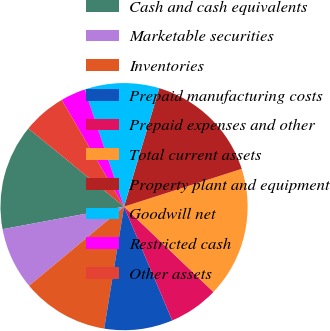Convert chart. <chart><loc_0><loc_0><loc_500><loc_500><pie_chart><fcel>Cash and cash equivalents<fcel>Marketable securities<fcel>Inventories<fcel>Prepaid manufacturing costs<fcel>Prepaid expenses and other<fcel>Total current assets<fcel>Property plant and equipment<fcel>Goodwill net<fcel>Restricted cash<fcel>Other assets<nl><fcel>13.82%<fcel>8.13%<fcel>11.38%<fcel>8.94%<fcel>6.5%<fcel>17.07%<fcel>15.45%<fcel>9.76%<fcel>3.25%<fcel>5.69%<nl></chart> 